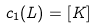<formula> <loc_0><loc_0><loc_500><loc_500>c _ { 1 } ( L ) = [ K ]</formula> 